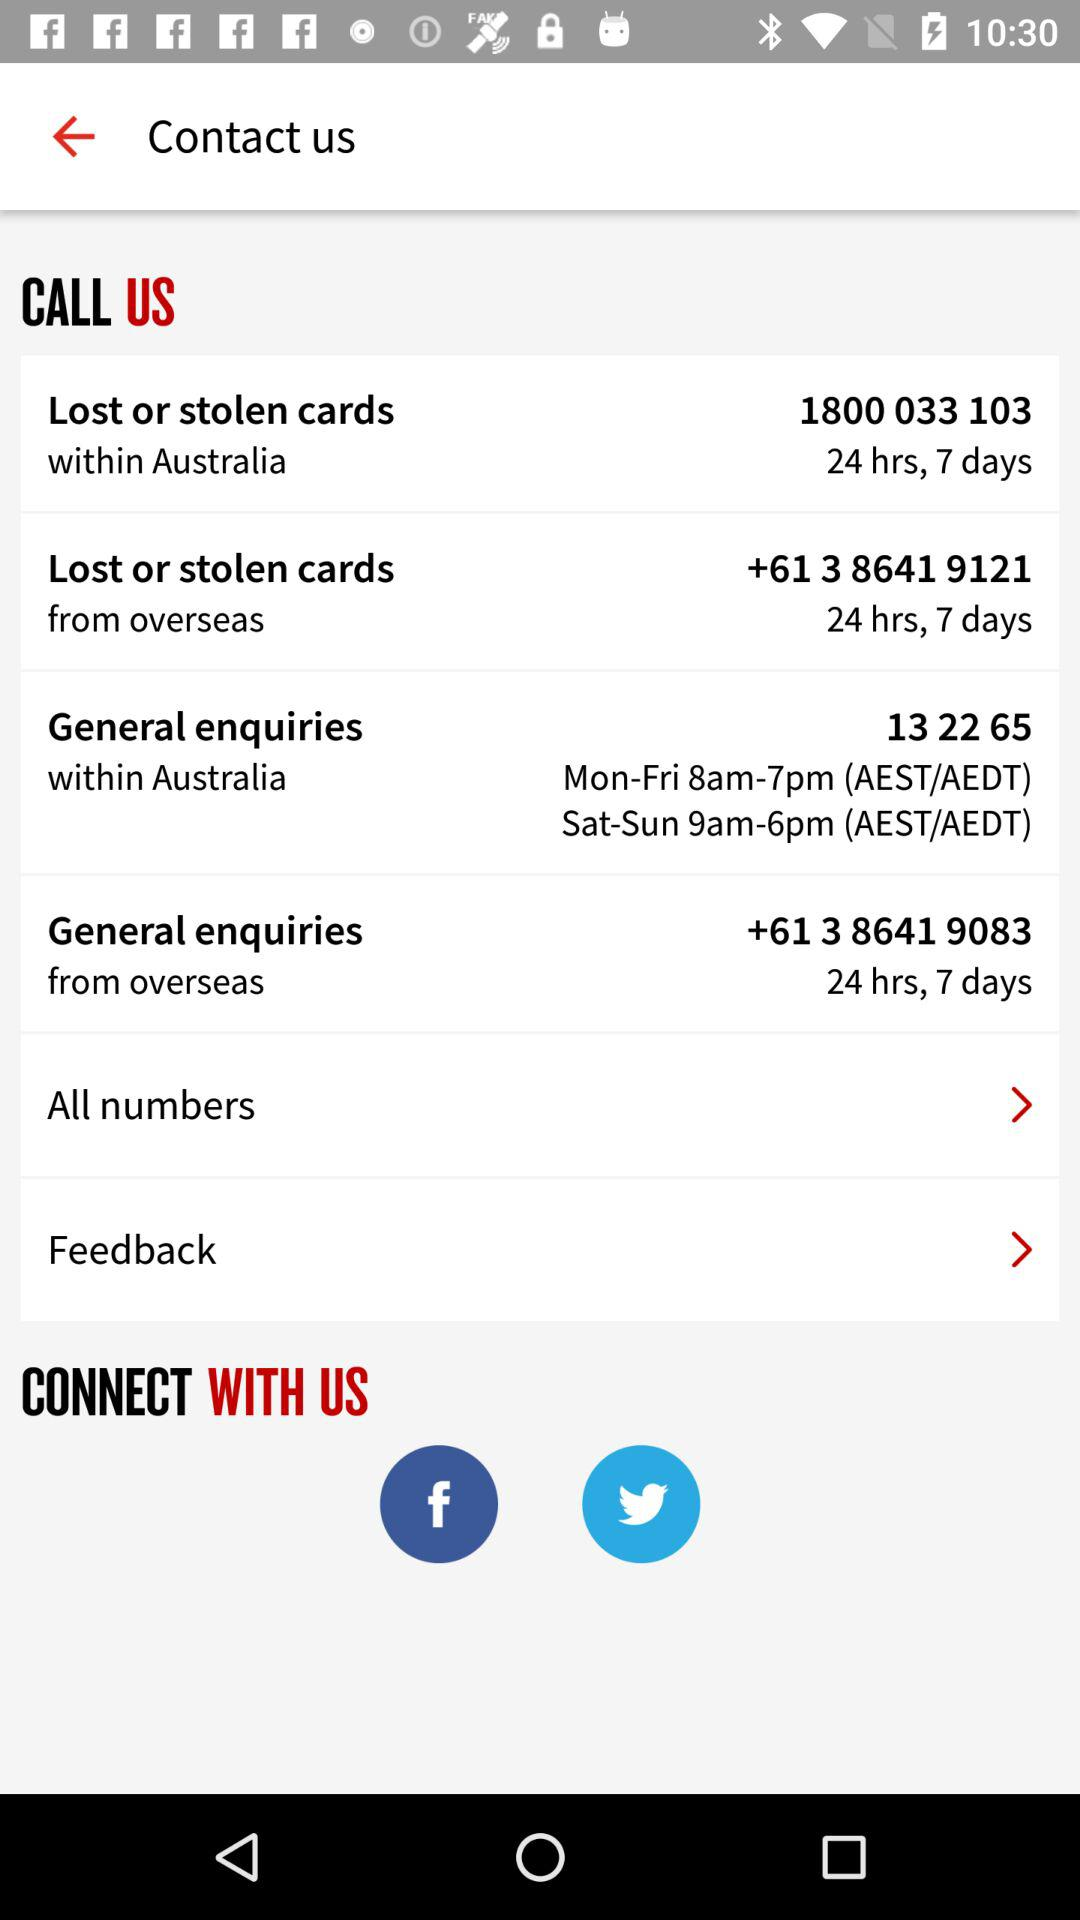What is the number to call for "Lost or stolen cards" from overseas? The number is +61 3 8641 9121. 